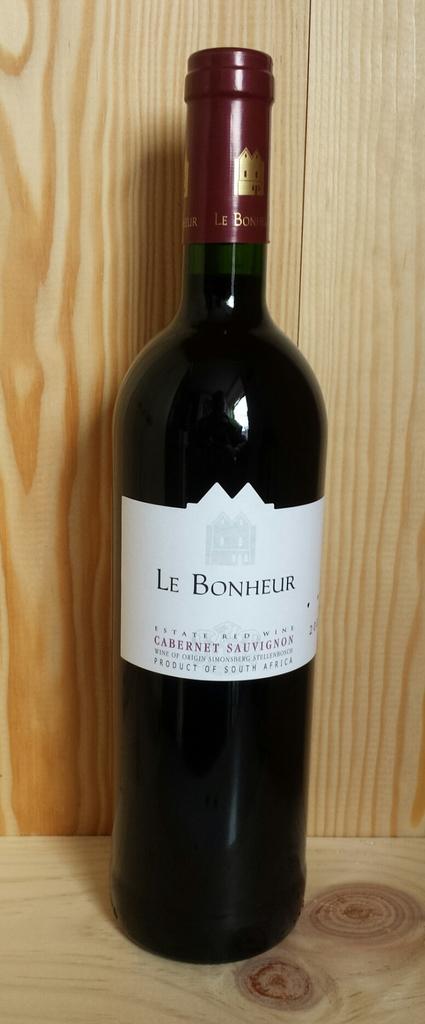What country was this wine made in?
Give a very brief answer. South africa. 